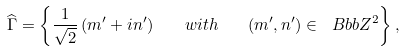<formula> <loc_0><loc_0><loc_500><loc_500>\widehat { \Gamma } = \left \{ \frac { 1 } { \sqrt { 2 } } \left ( m ^ { \prime } + i n ^ { \prime } \right ) \quad w i t h \quad ( m ^ { \prime } , n ^ { \prime } ) \in { \ B b b Z } ^ { 2 } \right \} ,</formula> 